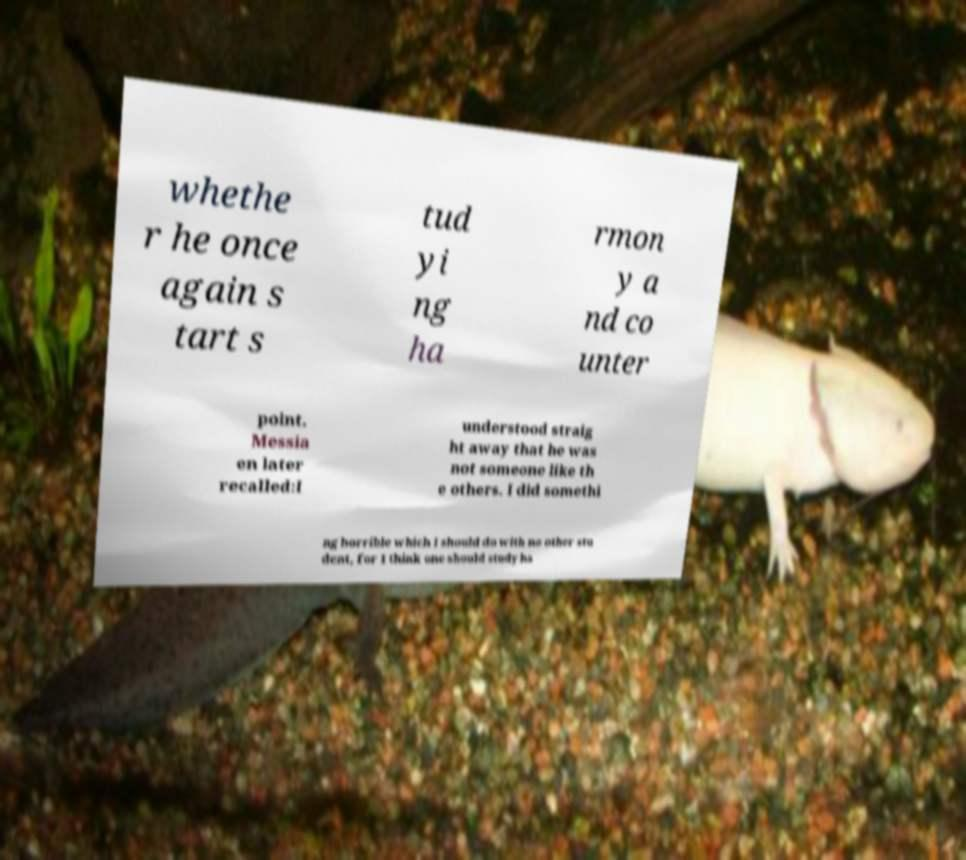Could you extract and type out the text from this image? whethe r he once again s tart s tud yi ng ha rmon y a nd co unter point. Messia en later recalled:I understood straig ht away that he was not someone like th e others. I did somethi ng horrible which I should do with no other stu dent, for I think one should study ha 